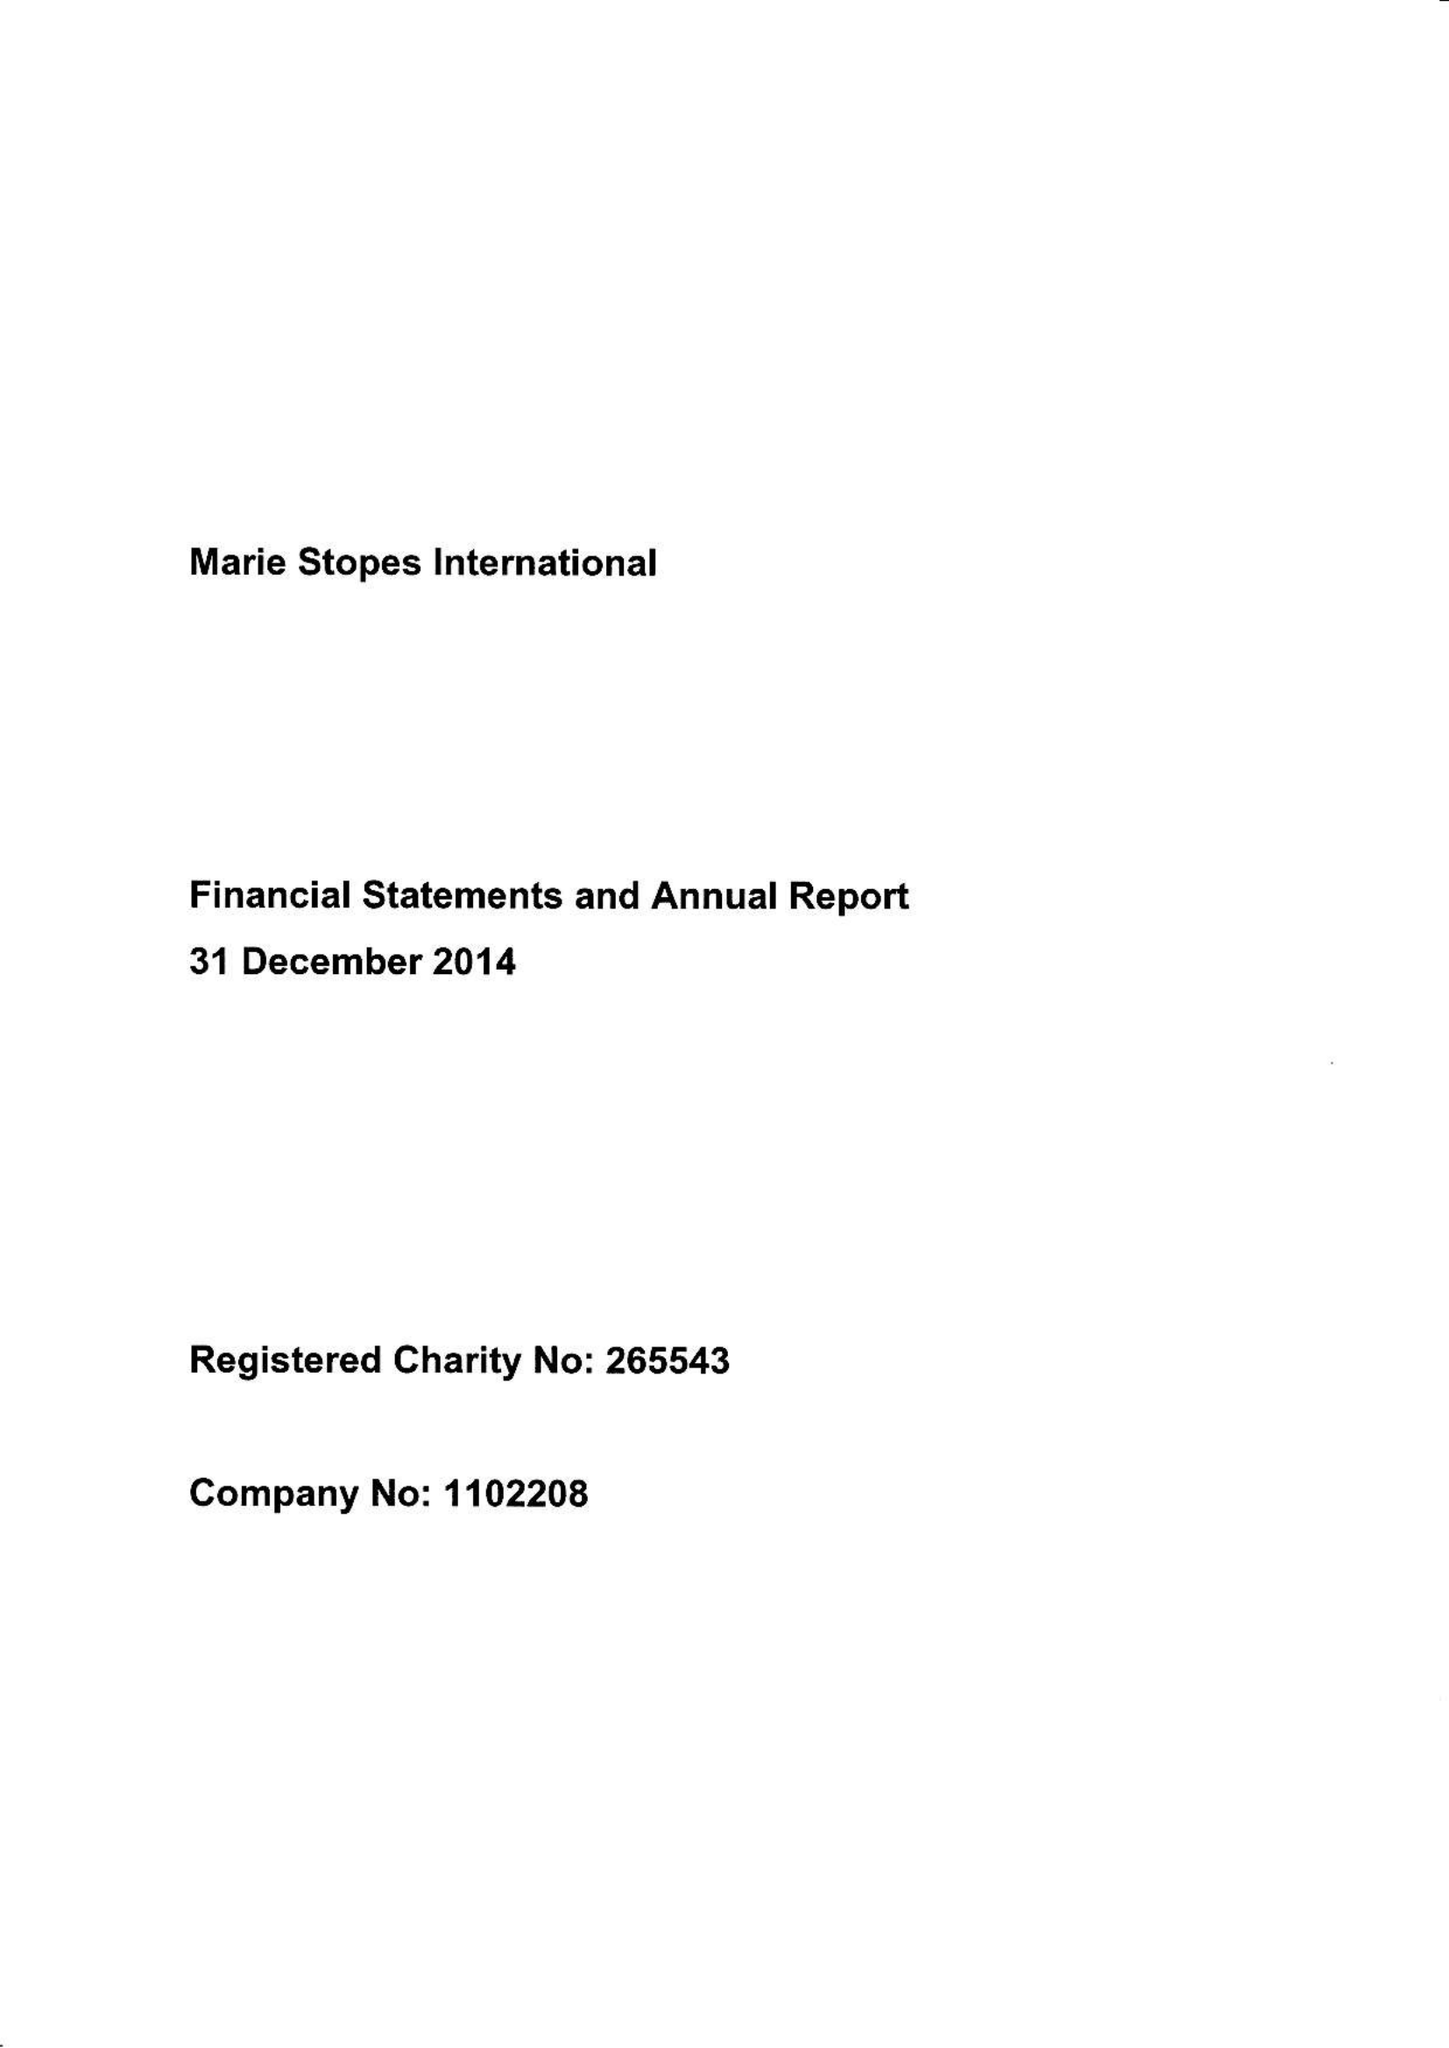What is the value for the address__street_line?
Answer the question using a single word or phrase. 1 CONWAY STREET 